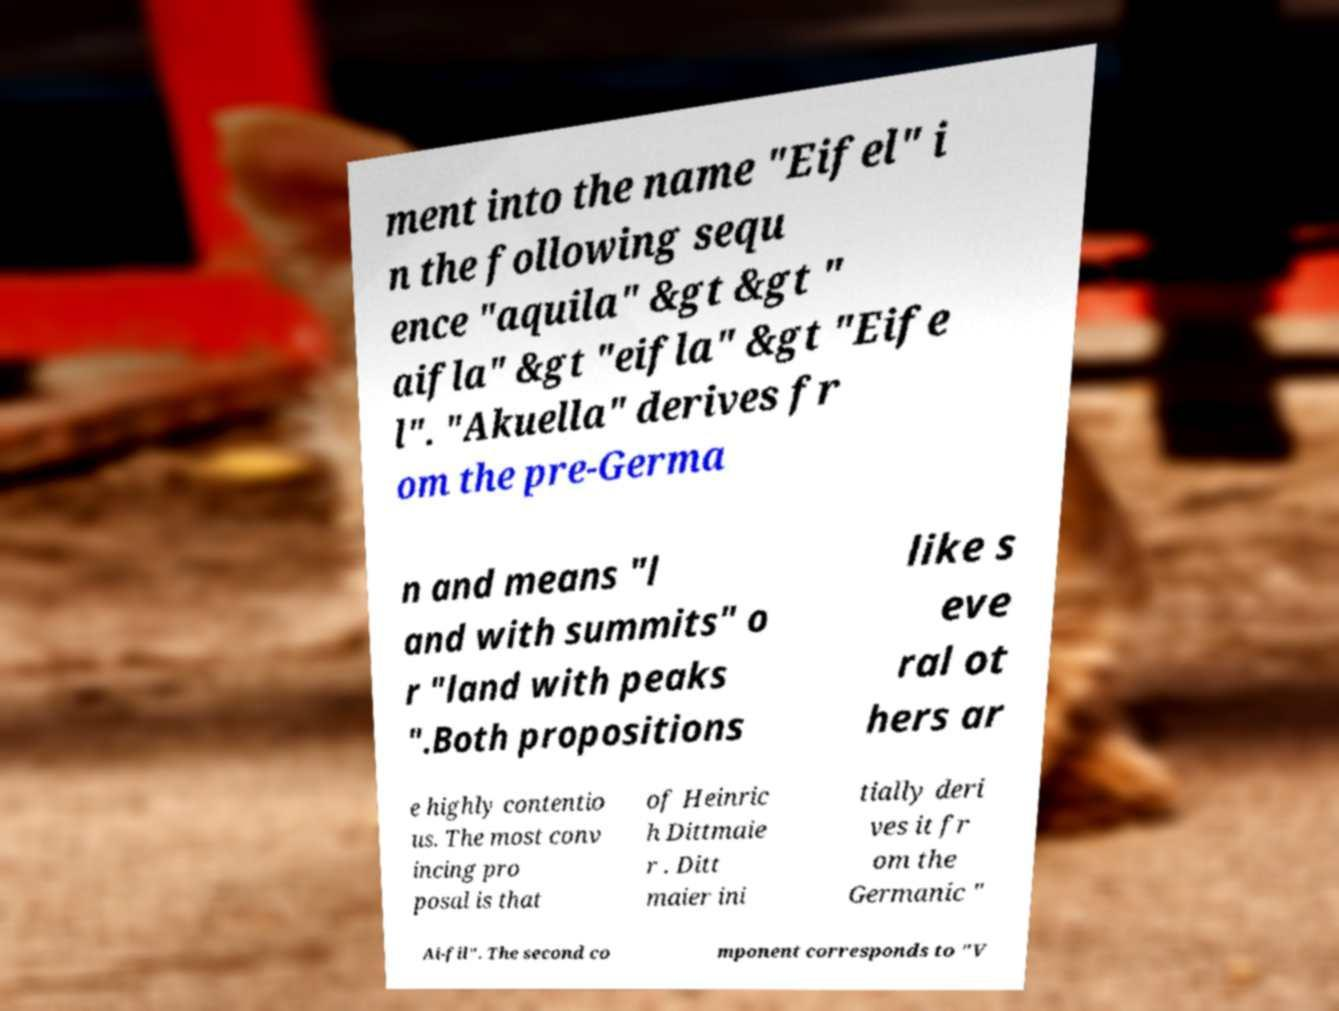What messages or text are displayed in this image? I need them in a readable, typed format. ment into the name "Eifel" i n the following sequ ence "aquila" &gt &gt " aifla" &gt "eifla" &gt "Eife l". "Akuella" derives fr om the pre-Germa n and means "l and with summits" o r "land with peaks ".Both propositions like s eve ral ot hers ar e highly contentio us. The most conv incing pro posal is that of Heinric h Dittmaie r . Ditt maier ini tially deri ves it fr om the Germanic " Ai-fil". The second co mponent corresponds to "V 